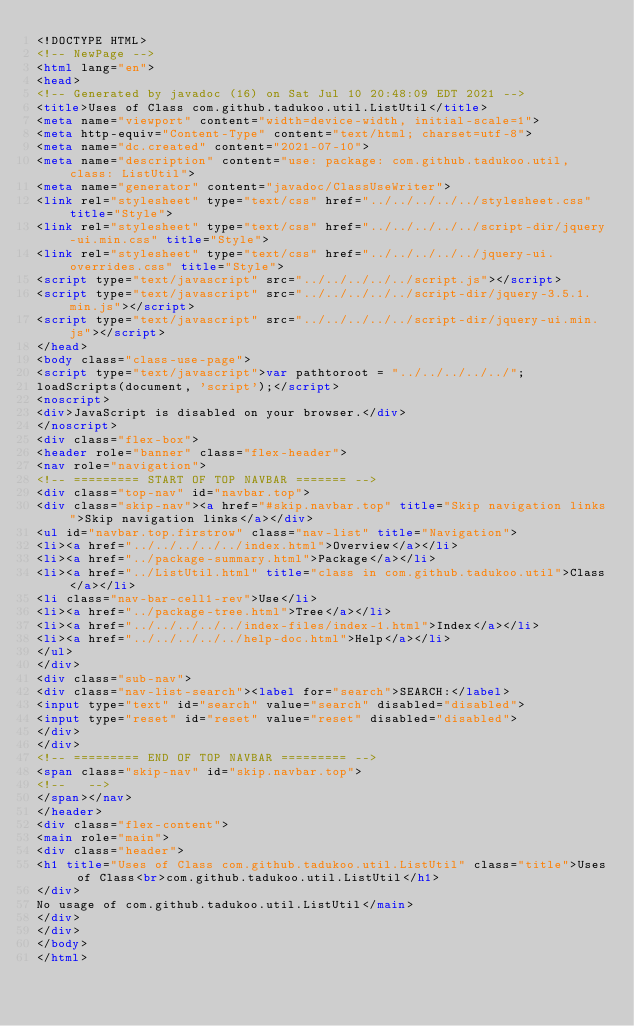Convert code to text. <code><loc_0><loc_0><loc_500><loc_500><_HTML_><!DOCTYPE HTML>
<!-- NewPage -->
<html lang="en">
<head>
<!-- Generated by javadoc (16) on Sat Jul 10 20:48:09 EDT 2021 -->
<title>Uses of Class com.github.tadukoo.util.ListUtil</title>
<meta name="viewport" content="width=device-width, initial-scale=1">
<meta http-equiv="Content-Type" content="text/html; charset=utf-8">
<meta name="dc.created" content="2021-07-10">
<meta name="description" content="use: package: com.github.tadukoo.util, class: ListUtil">
<meta name="generator" content="javadoc/ClassUseWriter">
<link rel="stylesheet" type="text/css" href="../../../../../stylesheet.css" title="Style">
<link rel="stylesheet" type="text/css" href="../../../../../script-dir/jquery-ui.min.css" title="Style">
<link rel="stylesheet" type="text/css" href="../../../../../jquery-ui.overrides.css" title="Style">
<script type="text/javascript" src="../../../../../script.js"></script>
<script type="text/javascript" src="../../../../../script-dir/jquery-3.5.1.min.js"></script>
<script type="text/javascript" src="../../../../../script-dir/jquery-ui.min.js"></script>
</head>
<body class="class-use-page">
<script type="text/javascript">var pathtoroot = "../../../../../";
loadScripts(document, 'script');</script>
<noscript>
<div>JavaScript is disabled on your browser.</div>
</noscript>
<div class="flex-box">
<header role="banner" class="flex-header">
<nav role="navigation">
<!-- ========= START OF TOP NAVBAR ======= -->
<div class="top-nav" id="navbar.top">
<div class="skip-nav"><a href="#skip.navbar.top" title="Skip navigation links">Skip navigation links</a></div>
<ul id="navbar.top.firstrow" class="nav-list" title="Navigation">
<li><a href="../../../../../index.html">Overview</a></li>
<li><a href="../package-summary.html">Package</a></li>
<li><a href="../ListUtil.html" title="class in com.github.tadukoo.util">Class</a></li>
<li class="nav-bar-cell1-rev">Use</li>
<li><a href="../package-tree.html">Tree</a></li>
<li><a href="../../../../../index-files/index-1.html">Index</a></li>
<li><a href="../../../../../help-doc.html">Help</a></li>
</ul>
</div>
<div class="sub-nav">
<div class="nav-list-search"><label for="search">SEARCH:</label>
<input type="text" id="search" value="search" disabled="disabled">
<input type="reset" id="reset" value="reset" disabled="disabled">
</div>
</div>
<!-- ========= END OF TOP NAVBAR ========= -->
<span class="skip-nav" id="skip.navbar.top">
<!--   -->
</span></nav>
</header>
<div class="flex-content">
<main role="main">
<div class="header">
<h1 title="Uses of Class com.github.tadukoo.util.ListUtil" class="title">Uses of Class<br>com.github.tadukoo.util.ListUtil</h1>
</div>
No usage of com.github.tadukoo.util.ListUtil</main>
</div>
</div>
</body>
</html>
</code> 